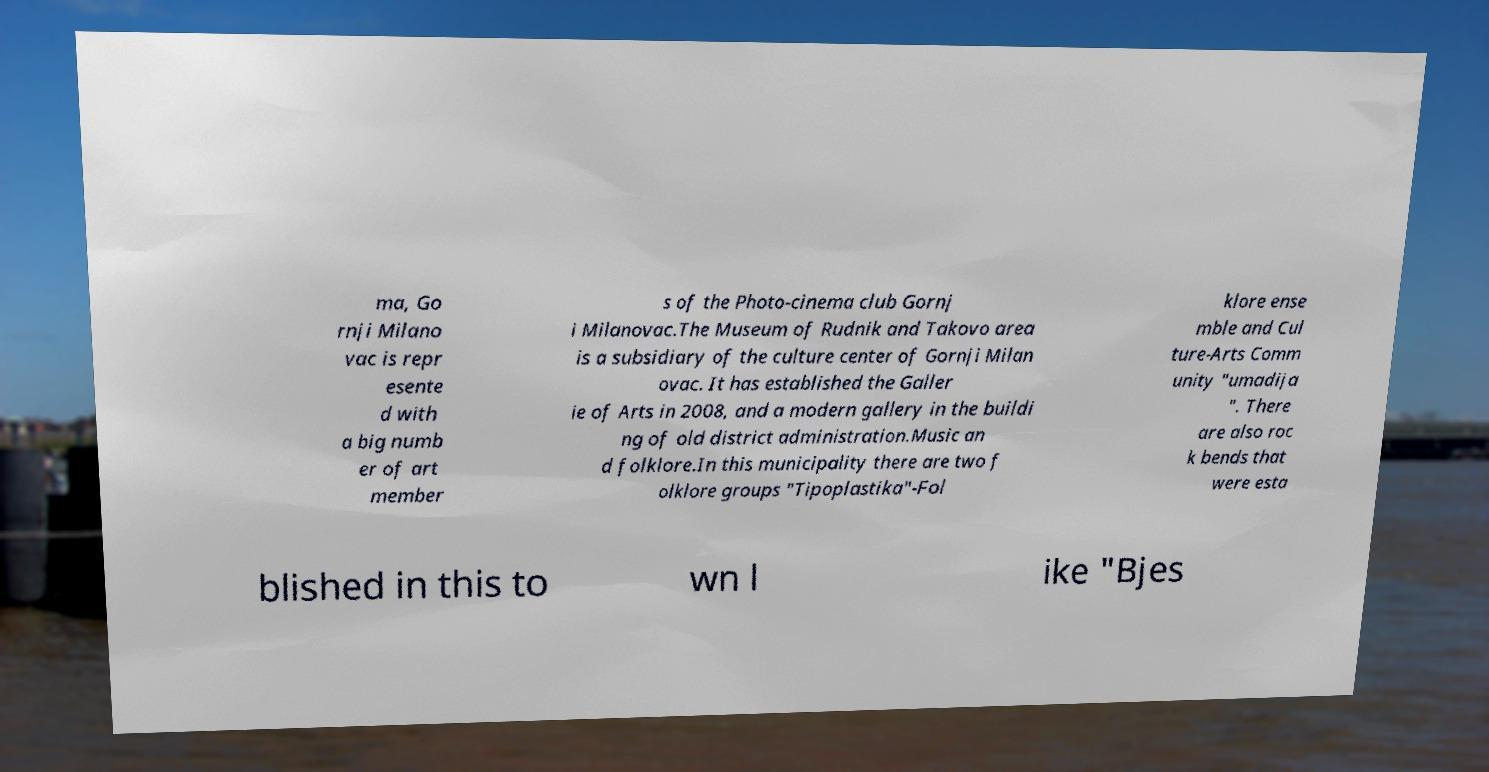Can you read and provide the text displayed in the image?This photo seems to have some interesting text. Can you extract and type it out for me? ma, Go rnji Milano vac is repr esente d with a big numb er of art member s of the Photo-cinema club Gornj i Milanovac.The Museum of Rudnik and Takovo area is a subsidiary of the culture center of Gornji Milan ovac. It has established the Galler ie of Arts in 2008, and a modern gallery in the buildi ng of old district administration.Music an d folklore.In this municipality there are two f olklore groups "Tipoplastika"-Fol klore ense mble and Cul ture-Arts Comm unity "umadija ". There are also roc k bends that were esta blished in this to wn l ike "Bjes 